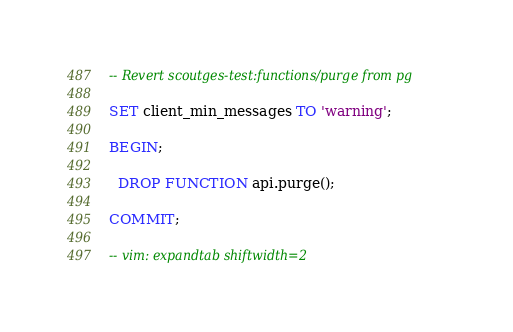<code> <loc_0><loc_0><loc_500><loc_500><_SQL_>-- Revert scoutges-test:functions/purge from pg

SET client_min_messages TO 'warning';

BEGIN;

  DROP FUNCTION api.purge();

COMMIT;

-- vim: expandtab shiftwidth=2
</code> 